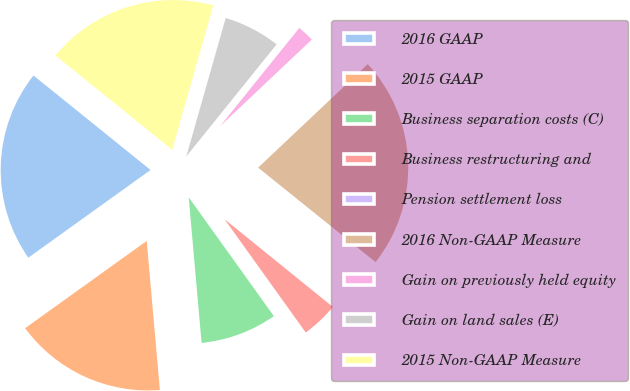Convert chart to OTSL. <chart><loc_0><loc_0><loc_500><loc_500><pie_chart><fcel>2016 GAAP<fcel>2015 GAAP<fcel>Business separation costs (C)<fcel>Business restructuring and<fcel>Pension settlement loss<fcel>2016 Non-GAAP Measure<fcel>Gain on previously held equity<fcel>Gain on land sales (E)<fcel>2015 Non-GAAP Measure<nl><fcel>20.71%<fcel>16.49%<fcel>8.49%<fcel>4.27%<fcel>0.05%<fcel>22.82%<fcel>2.16%<fcel>6.38%<fcel>18.6%<nl></chart> 